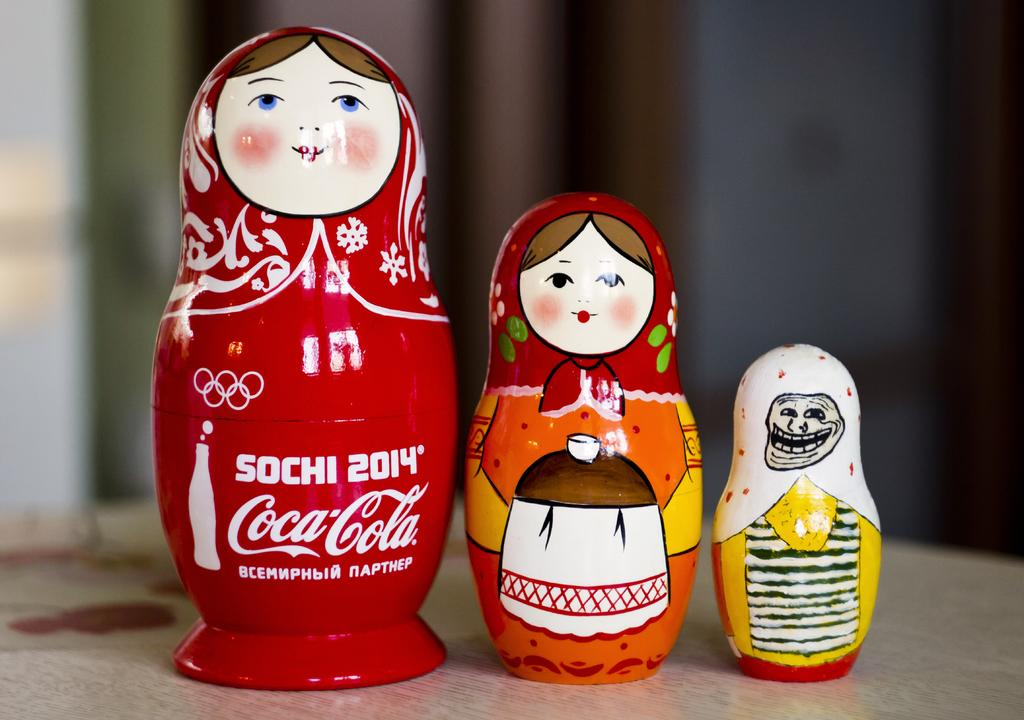How many dolls are present in the image? There are 3 dolls in the image. Can you describe any text or writing visible in the image? There is text or writing in the image, but it is blurred in the background. What type of alley can be seen behind the dolls in the image? There is no alley visible in the image; it only features dolls and blurred text or writing in the background. 